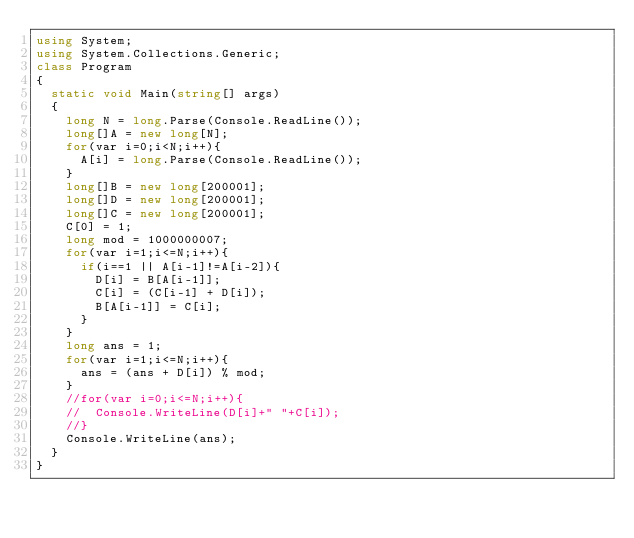Convert code to text. <code><loc_0><loc_0><loc_500><loc_500><_C#_>using System;
using System.Collections.Generic;
class Program
{
	static void Main(string[] args)
	{
		long N = long.Parse(Console.ReadLine());
		long[]A = new long[N];
		for(var i=0;i<N;i++){
			A[i] = long.Parse(Console.ReadLine());
		}
		long[]B = new long[200001];
		long[]D = new long[200001];
		long[]C = new long[200001];
		C[0] = 1;
		long mod = 1000000007;
		for(var i=1;i<=N;i++){
			if(i==1 || A[i-1]!=A[i-2]){
				D[i] = B[A[i-1]];
				C[i] = (C[i-1] + D[i]);
				B[A[i-1]] = C[i];
			}
		}
		long ans = 1;
		for(var i=1;i<=N;i++){
			ans = (ans + D[i]) % mod;
		}
		//for(var i=0;i<=N;i++){
		//	Console.WriteLine(D[i]+" "+C[i]);
		//}
		Console.WriteLine(ans);
	}
}</code> 